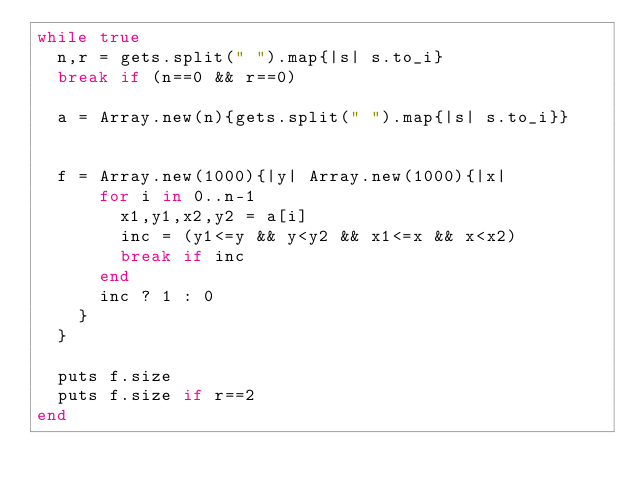<code> <loc_0><loc_0><loc_500><loc_500><_Ruby_>while true
  n,r = gets.split(" ").map{|s| s.to_i}
  break if (n==0 && r==0)
  
  a = Array.new(n){gets.split(" ").map{|s| s.to_i}}
  

  f = Array.new(1000){|y| Array.new(1000){|x|
      for i in 0..n-1
        x1,y1,x2,y2 = a[i]
        inc = (y1<=y && y<y2 && x1<=x && x<x2)
        break if inc
      end
      inc ? 1 : 0
    }
  }

  puts f.size
  puts f.size if r==2
end</code> 